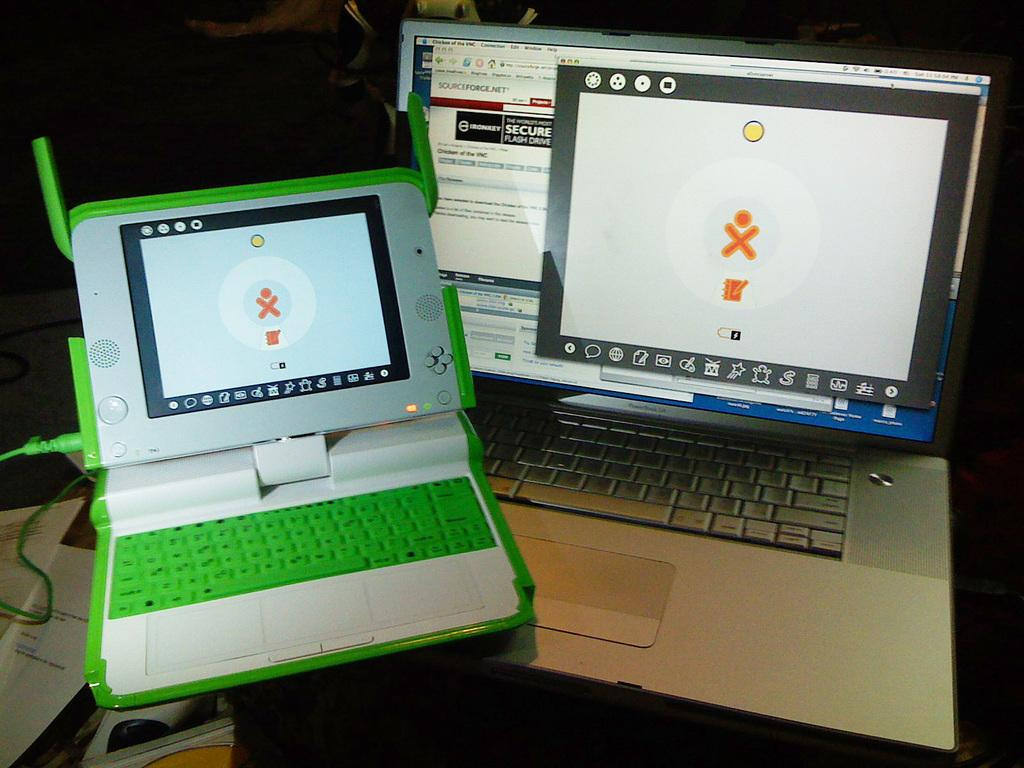<image>
Create a compact narrative representing the image presented. One of the computer screens has the word sourceforge.net on it 